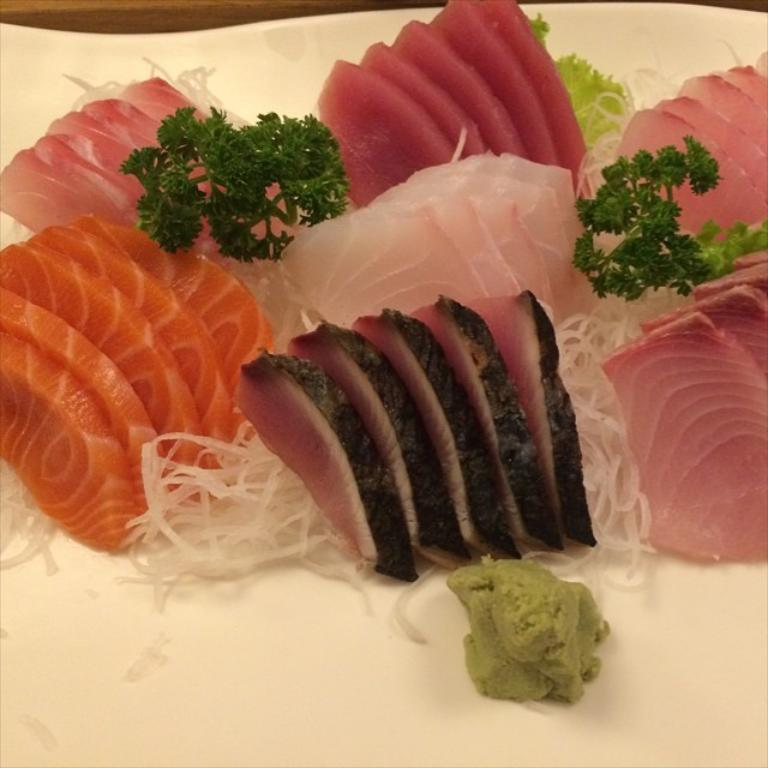What type of food is on the plate in the image? There are pieces of meat, tomatoes, onions, cucumbers, and mint on a plate. Can you describe the vegetables on the plate? The vegetables on the plate include tomatoes, onions, and cucumbers. What herb is present on the plate? Mint is present on the plate. Where is the plate located in the image? The plate is kept on a table. What type of treatment is being administered to the boys in the image? There are no boys or any indication of treatment in the image; it features a plate with food items on a table. 